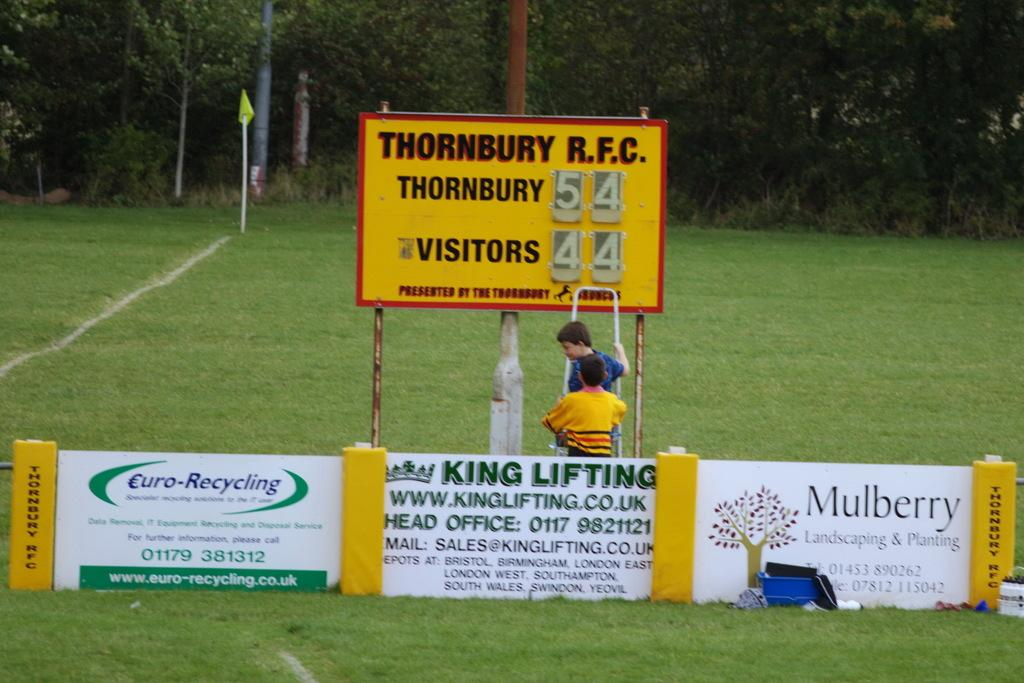Provide a one-sentence caption for the provided image. A group of children change the score on a Thornbury RFC score card. 